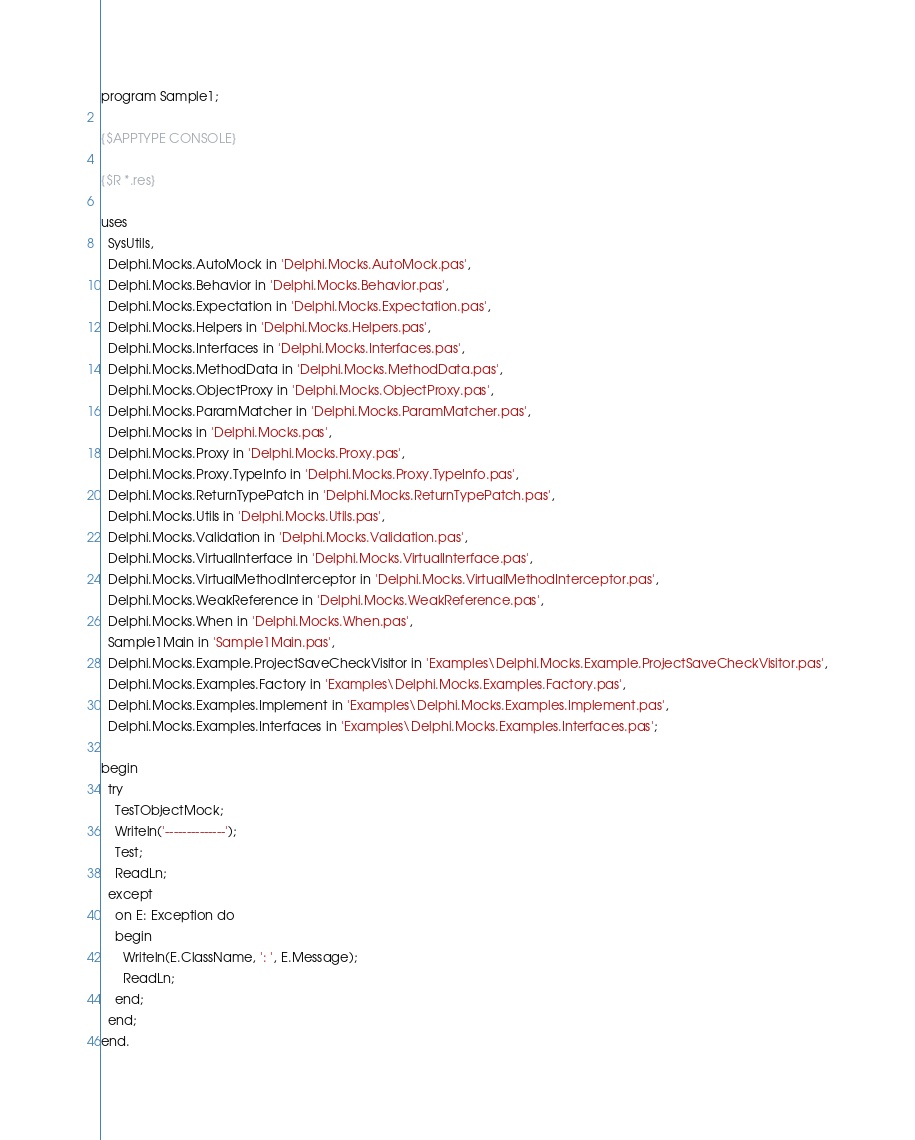Convert code to text. <code><loc_0><loc_0><loc_500><loc_500><_Pascal_>program Sample1;

{$APPTYPE CONSOLE}

{$R *.res}

uses
  SysUtils,
  Delphi.Mocks.AutoMock in 'Delphi.Mocks.AutoMock.pas',
  Delphi.Mocks.Behavior in 'Delphi.Mocks.Behavior.pas',
  Delphi.Mocks.Expectation in 'Delphi.Mocks.Expectation.pas',
  Delphi.Mocks.Helpers in 'Delphi.Mocks.Helpers.pas',
  Delphi.Mocks.Interfaces in 'Delphi.Mocks.Interfaces.pas',
  Delphi.Mocks.MethodData in 'Delphi.Mocks.MethodData.pas',
  Delphi.Mocks.ObjectProxy in 'Delphi.Mocks.ObjectProxy.pas',
  Delphi.Mocks.ParamMatcher in 'Delphi.Mocks.ParamMatcher.pas',
  Delphi.Mocks in 'Delphi.Mocks.pas',
  Delphi.Mocks.Proxy in 'Delphi.Mocks.Proxy.pas',
  Delphi.Mocks.Proxy.TypeInfo in 'Delphi.Mocks.Proxy.TypeInfo.pas',
  Delphi.Mocks.ReturnTypePatch in 'Delphi.Mocks.ReturnTypePatch.pas',
  Delphi.Mocks.Utils in 'Delphi.Mocks.Utils.pas',
  Delphi.Mocks.Validation in 'Delphi.Mocks.Validation.pas',
  Delphi.Mocks.VirtualInterface in 'Delphi.Mocks.VirtualInterface.pas',
  Delphi.Mocks.VirtualMethodInterceptor in 'Delphi.Mocks.VirtualMethodInterceptor.pas',
  Delphi.Mocks.WeakReference in 'Delphi.Mocks.WeakReference.pas',
  Delphi.Mocks.When in 'Delphi.Mocks.When.pas',
  Sample1Main in 'Sample1Main.pas',
  Delphi.Mocks.Example.ProjectSaveCheckVisitor in 'Examples\Delphi.Mocks.Example.ProjectSaveCheckVisitor.pas',
  Delphi.Mocks.Examples.Factory in 'Examples\Delphi.Mocks.Examples.Factory.pas',
  Delphi.Mocks.Examples.Implement in 'Examples\Delphi.Mocks.Examples.Implement.pas',
  Delphi.Mocks.Examples.Interfaces in 'Examples\Delphi.Mocks.Examples.Interfaces.pas';

begin
  try
    TesTObjectMock;
    Writeln('--------------');
    Test;
    ReadLn;
  except
    on E: Exception do
    begin
      Writeln(E.ClassName, ': ', E.Message);
      ReadLn;
    end;
  end;
end.
</code> 